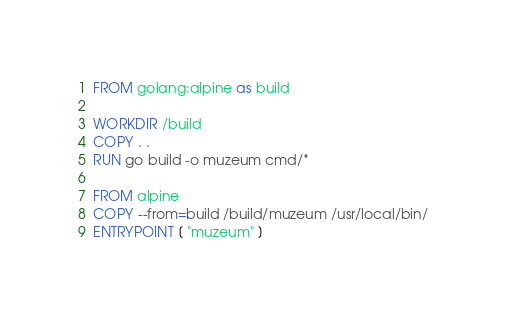Convert code to text. <code><loc_0><loc_0><loc_500><loc_500><_Dockerfile_>FROM golang:alpine as build

WORKDIR /build
COPY . .
RUN go build -o muzeum cmd/* 

FROM alpine
COPY --from=build /build/muzeum /usr/local/bin/
ENTRYPOINT [ "muzeum" ]








</code> 